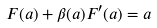<formula> <loc_0><loc_0><loc_500><loc_500>F ( a ) + \beta ( a ) F ^ { \prime } ( a ) = a</formula> 